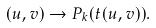<formula> <loc_0><loc_0><loc_500><loc_500>( u , v ) \to P _ { k } ( t ( u , v ) ) .</formula> 